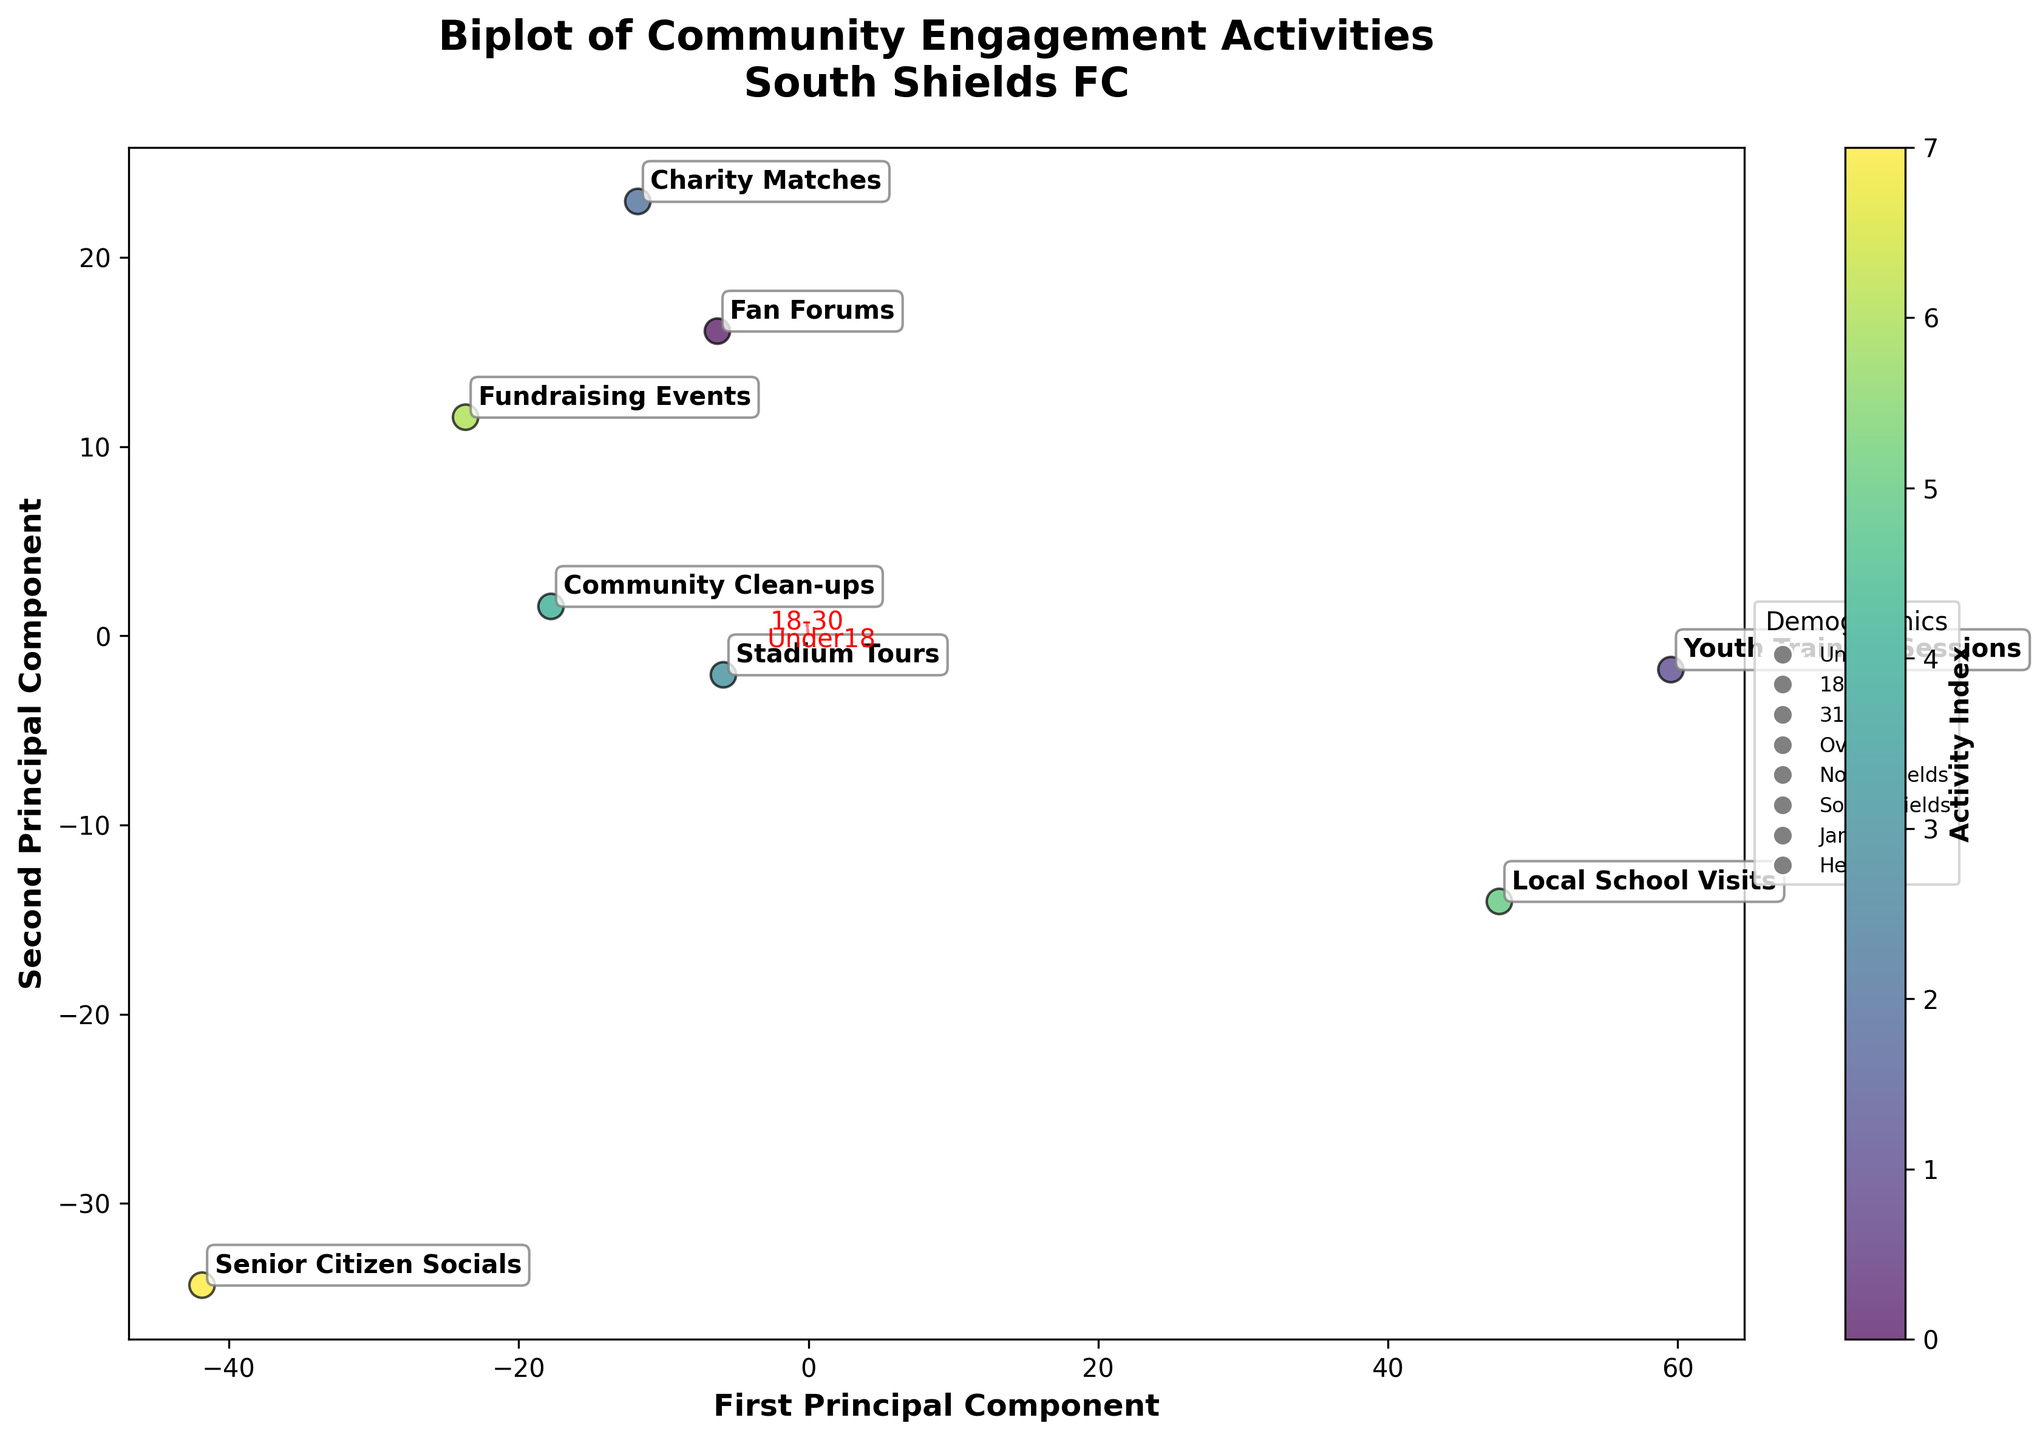Which activity has the highest engagement from the Under18 age group? Look at the coordinates for activities associated with the Under18 age group and find the one with the highest value. "Youth Training Sessions" is the activity with the highest engagement in this age group.
Answer: Youth Training Sessions Which local area has the highest participation in "Charity Matches"? Look at the coordinates for "Charity Matches" and identify the local area with the highest coordinate value related to it. "South Shields" shows the highest participation for this activity.
Answer: South Shields Which age group is least engaged in "Senior Citizen Socials"? Find the coordinates for "Senior Citizen Socials" and identify the lowest value among age groups. The Under18 group has the lowest engagement.
Answer: Under18 Compare the engagement levels in "Community Clean-ups" between the age group 31-50 and Over50. Look at the biplot and compare the coordinate values of "Community Clean-ups" for these two age groups. For "Community Clean-ups," the value for 31-50 is lower than that for Over50.
Answer: Over50 > 31-50 Which activity has the most balanced engagement across all age groups? Identify the activity with coordinates that are closest to the origin or show the least dispersion across the axes representing age groups. "Stadium Tours" appear relatively balanced across all age groups.
Answer: Stadium Tours What activity shows the highest overall community engagement across the local areas? Find the activity with the highest cumulative values or the furthest displacement from the origin for all local areas combined. "Charity Matches" and “Fundraising Events” show high overall engagement across all local areas.
Answer: Charity Matches and Fundraising Events Which local area seems to most engage with activities targeting younger demographics? Look at the position of vectors for local areas and their alignment with activities showing high engagement values for younger age groups like Under18 and 18-30. "South Shields" shows high engagement in "Youth Training Sessions" which targets younger demographics.
Answer: South Shields Which activity involves the greatest participation from North Shields? Identify the activity where North Shields has the highest coordinate value. For "Youth Training Sessions," North Shields shows a high participation level.
Answer: Youth Training Sessions 